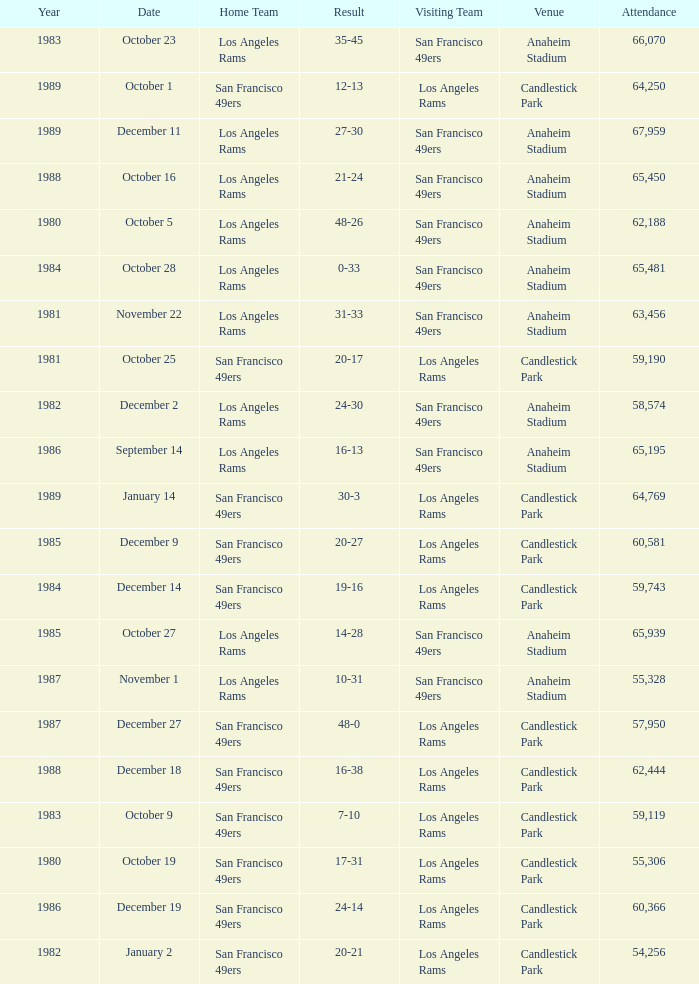What's the total attendance at anaheim stadium after 1983 when the result is 14-28? 1.0. 